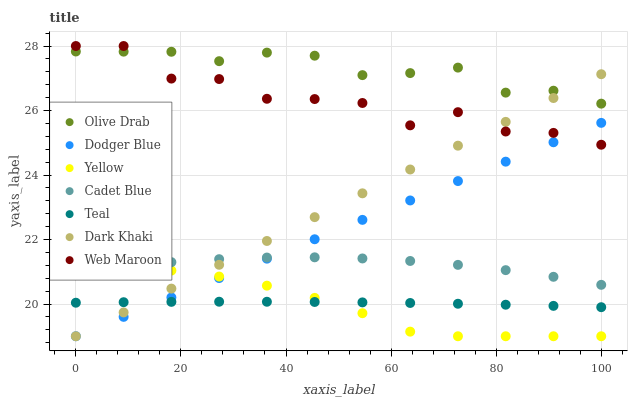Does Yellow have the minimum area under the curve?
Answer yes or no. Yes. Does Olive Drab have the maximum area under the curve?
Answer yes or no. Yes. Does Web Maroon have the minimum area under the curve?
Answer yes or no. No. Does Web Maroon have the maximum area under the curve?
Answer yes or no. No. Is Dark Khaki the smoothest?
Answer yes or no. Yes. Is Web Maroon the roughest?
Answer yes or no. Yes. Is Yellow the smoothest?
Answer yes or no. No. Is Yellow the roughest?
Answer yes or no. No. Does Yellow have the lowest value?
Answer yes or no. Yes. Does Web Maroon have the lowest value?
Answer yes or no. No. Does Web Maroon have the highest value?
Answer yes or no. Yes. Does Yellow have the highest value?
Answer yes or no. No. Is Teal less than Olive Drab?
Answer yes or no. Yes. Is Olive Drab greater than Teal?
Answer yes or no. Yes. Does Web Maroon intersect Dark Khaki?
Answer yes or no. Yes. Is Web Maroon less than Dark Khaki?
Answer yes or no. No. Is Web Maroon greater than Dark Khaki?
Answer yes or no. No. Does Teal intersect Olive Drab?
Answer yes or no. No. 